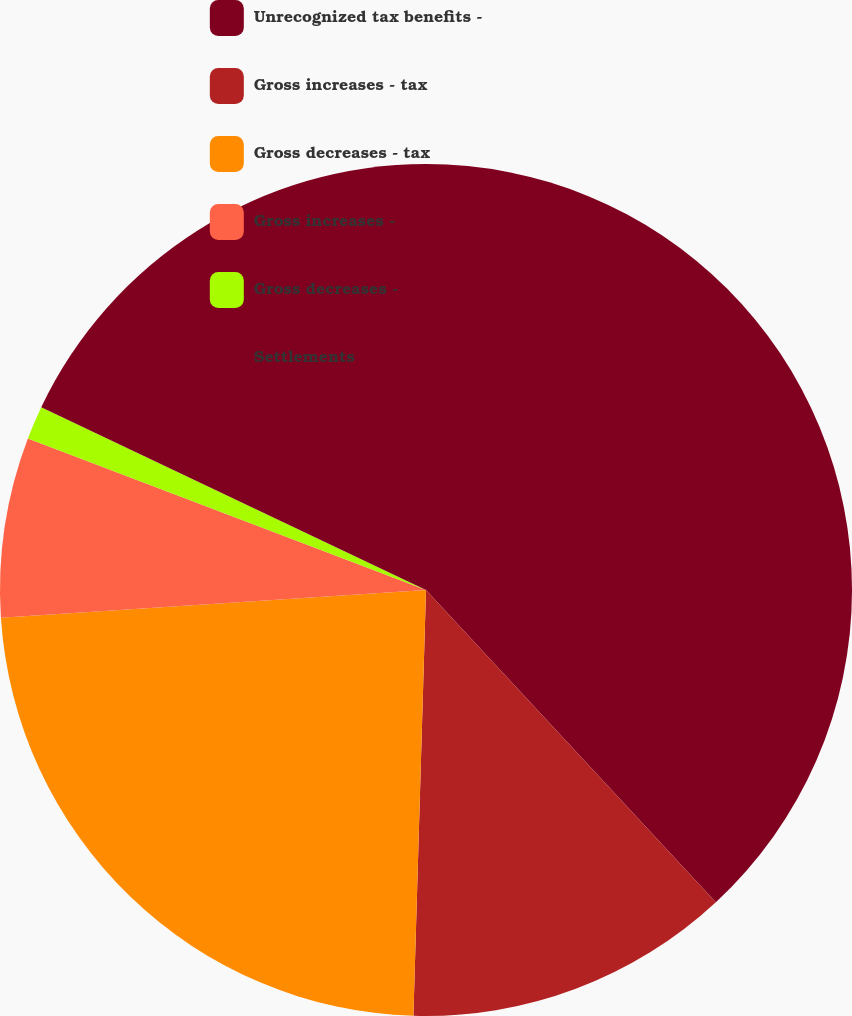<chart> <loc_0><loc_0><loc_500><loc_500><pie_chart><fcel>Unrecognized tax benefits -<fcel>Gross increases - tax<fcel>Gross decreases - tax<fcel>Gross increases -<fcel>Gross decreases -<fcel>Settlements<nl><fcel>38.09%<fcel>12.38%<fcel>23.49%<fcel>6.83%<fcel>1.27%<fcel>17.94%<nl></chart> 